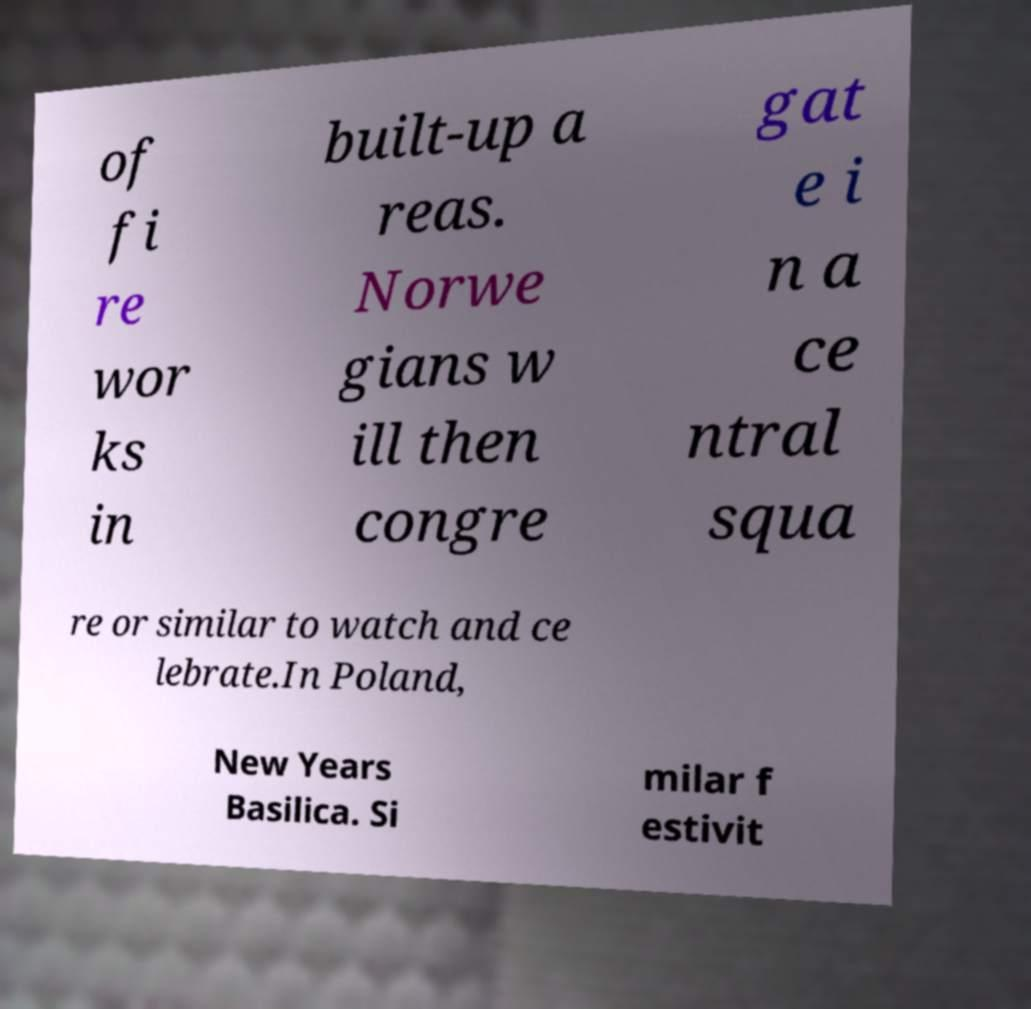I need the written content from this picture converted into text. Can you do that? of fi re wor ks in built-up a reas. Norwe gians w ill then congre gat e i n a ce ntral squa re or similar to watch and ce lebrate.In Poland, New Years Basilica. Si milar f estivit 